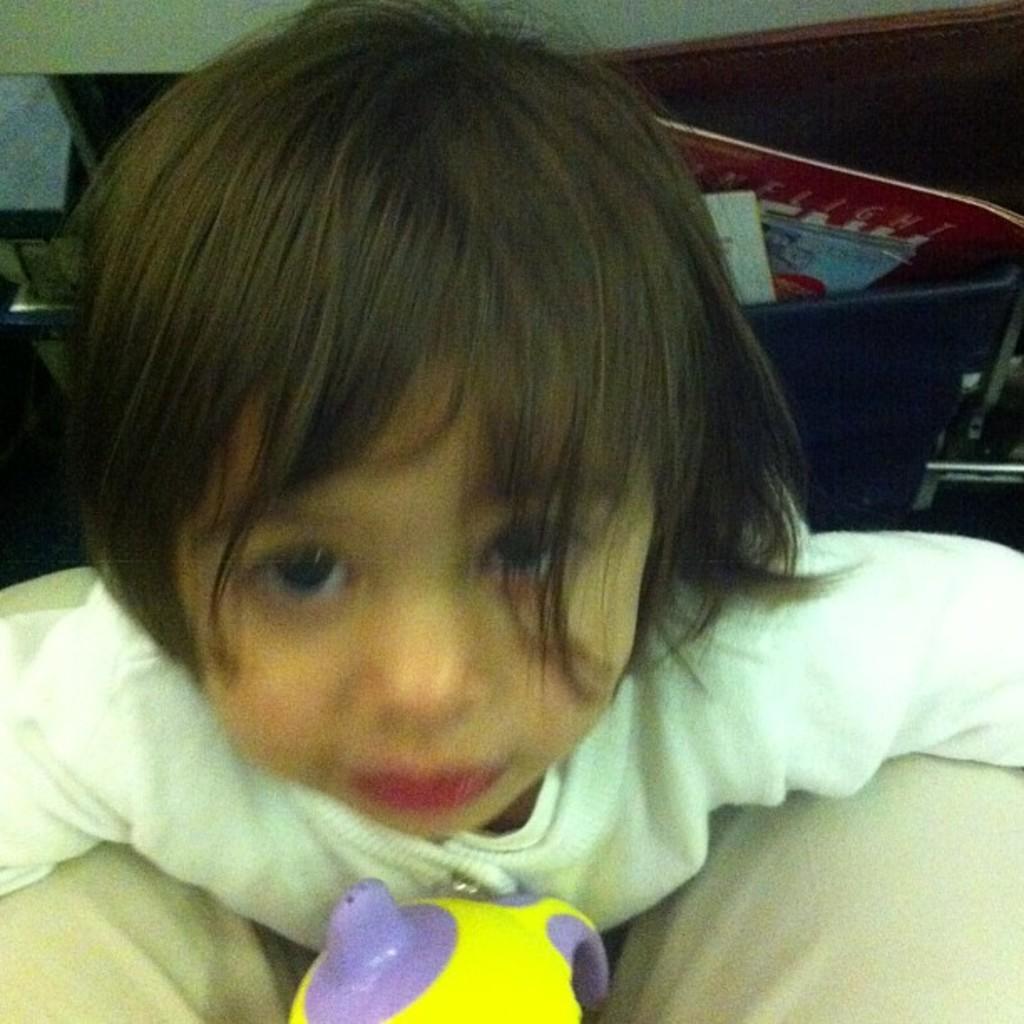Describe this image in one or two sentences. There is a girl, in front of this girl we can see toy. In the background we can see book and few objects. 